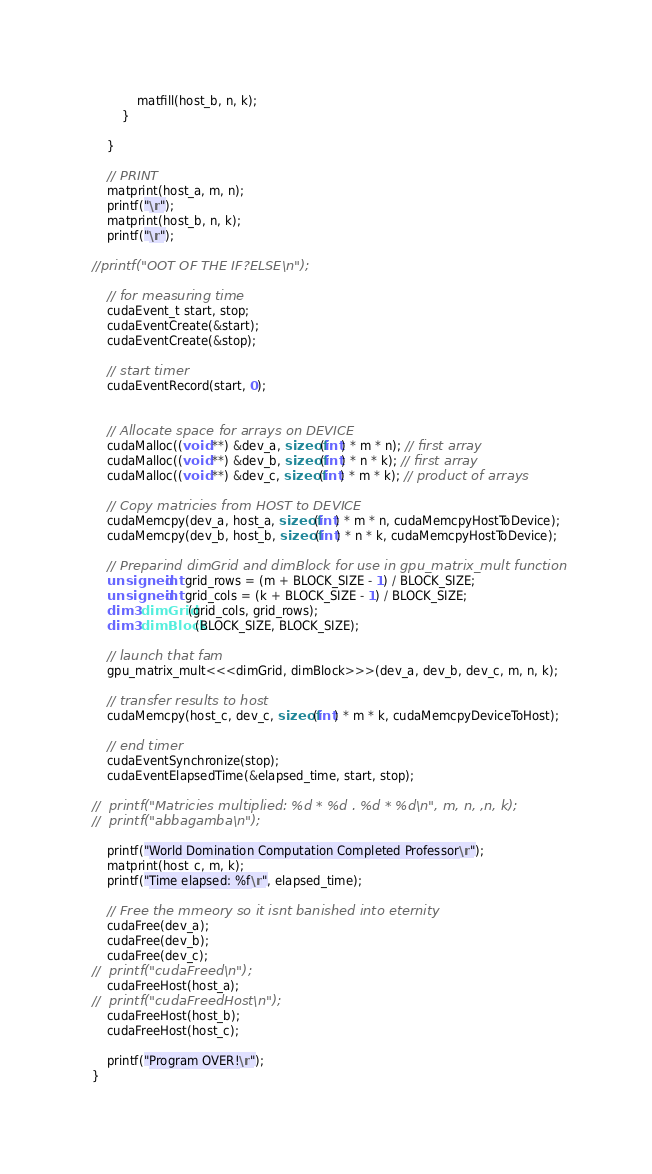<code> <loc_0><loc_0><loc_500><loc_500><_Cuda_>			matfill(host_b, n, k);
		}

	}

	// PRINT
	matprint(host_a, m, n);
	printf("\n");
	matprint(host_b, n, k);
	printf("\n");

//printf("OOT OF THE IF?ELSE\n");

	// for measuring time	
	cudaEvent_t start, stop;
	cudaEventCreate(&start);
	cudaEventCreate(&stop);

	// start timer
	cudaEventRecord(start, 0);
	
	
	// Allocate space for arrays on DEVICE
	cudaMalloc((void **) &dev_a, sizeof(int) * m * n); // first array
	cudaMalloc((void **) &dev_b, sizeof(int) * n * k); // first array
	cudaMalloc((void **) &dev_c, sizeof(int) * m * k); // product of arrays

	// Copy matricies from HOST to DEVICE
	cudaMemcpy(dev_a, host_a, sizeof(int) * m * n, cudaMemcpyHostToDevice);
	cudaMemcpy(dev_b, host_b, sizeof(int) * n * k, cudaMemcpyHostToDevice);

	// Preparind dimGrid and dimBlock for use in gpu_matrix_mult function
	unsigned int grid_rows = (m + BLOCK_SIZE - 1) / BLOCK_SIZE; 
	unsigned int grid_cols = (k + BLOCK_SIZE - 1) / BLOCK_SIZE; 
	dim3 dimGrid(grid_cols, grid_rows);
	dim3 dimBlock(BLOCK_SIZE, BLOCK_SIZE);

	// launch that fam
	gpu_matrix_mult<<<dimGrid, dimBlock>>>(dev_a, dev_b, dev_c, m, n, k);

	// transfer results to host
	cudaMemcpy(host_c, dev_c, sizeof(int) * m * k, cudaMemcpyDeviceToHost);

	// end timer
	cudaEventSynchronize(stop);
	cudaEventElapsedTime(&elapsed_time, start, stop);
	
//	printf("Matricies multiplied: %d * %d . %d * %d\n", m, n, ,n, k);
//	printf("abbagamba\n");

	printf("World Domination Computation Completed Professor\n");
	matprint(host_c, m, k);
	printf("Time elapsed: %f\n", elapsed_time);

	// Free the mmeory so it isnt banished into eternity
	cudaFree(dev_a);
	cudaFree(dev_b);
	cudaFree(dev_c);
//	printf("cudaFreed\n");
	cudaFreeHost(host_a);
//	printf("cudaFreedHost\n");
	cudaFreeHost(host_b);
	cudaFreeHost(host_c);

	printf("Program OVER!\n");
}
</code> 